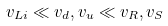<formula> <loc_0><loc_0><loc_500><loc_500>v _ { L i } \ll v _ { d } , v _ { u } \ll v _ { R } , v _ { S }</formula> 